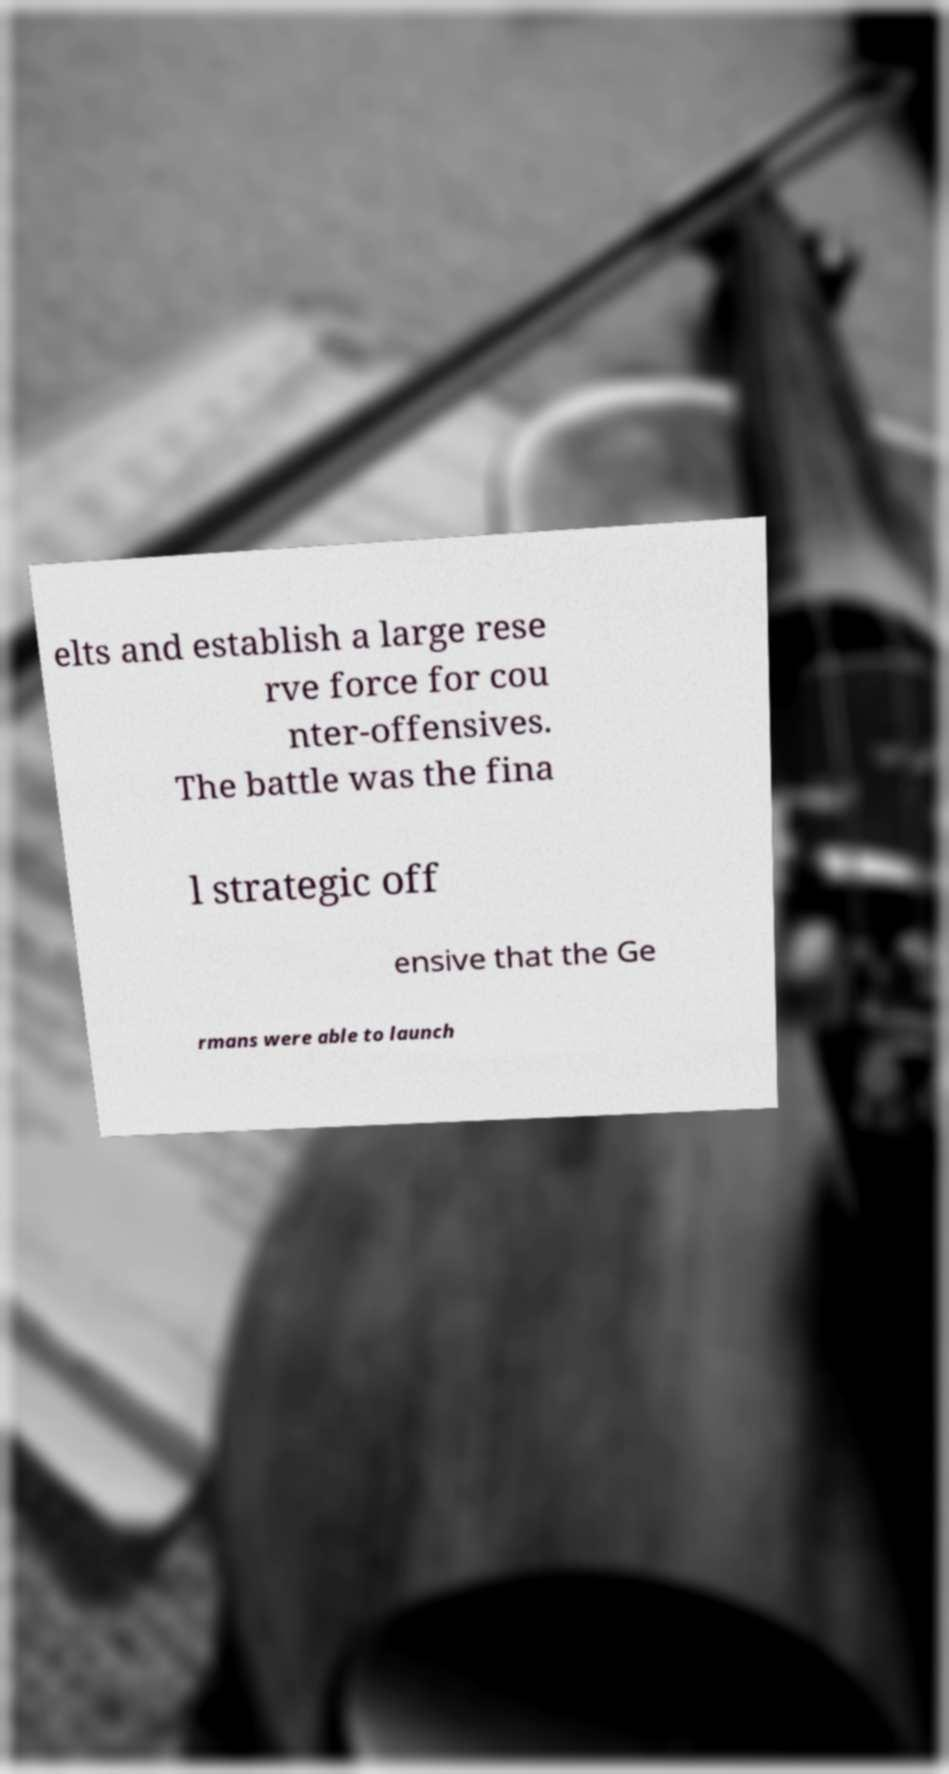Please identify and transcribe the text found in this image. elts and establish a large rese rve force for cou nter-offensives. The battle was the fina l strategic off ensive that the Ge rmans were able to launch 